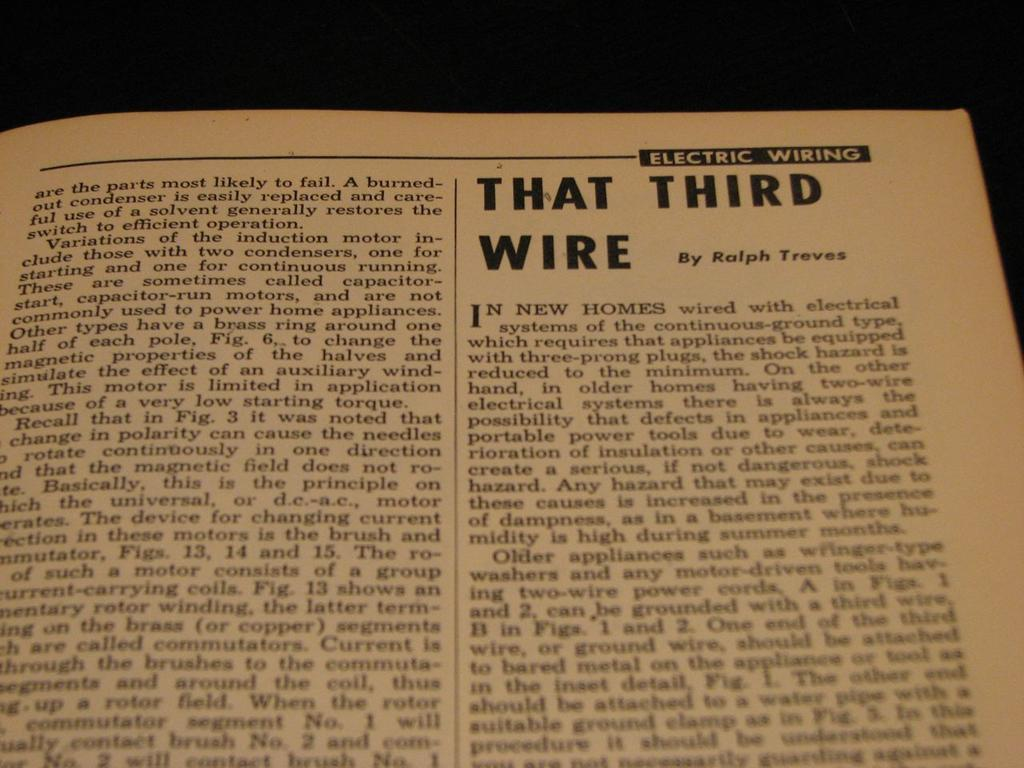<image>
Write a terse but informative summary of the picture. An article about electric wiring that was written by Ralph Treves. 